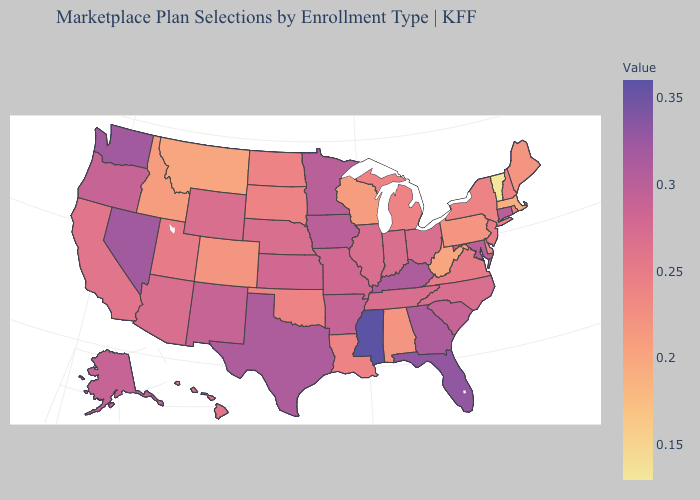Which states have the lowest value in the MidWest?
Write a very short answer. Wisconsin. Among the states that border Mississippi , which have the highest value?
Give a very brief answer. Arkansas. Among the states that border Pennsylvania , which have the lowest value?
Answer briefly. West Virginia. Does Pennsylvania have a lower value than Vermont?
Keep it brief. No. Among the states that border Nebraska , which have the lowest value?
Give a very brief answer. Colorado. Does Tennessee have the lowest value in the USA?
Be succinct. No. 